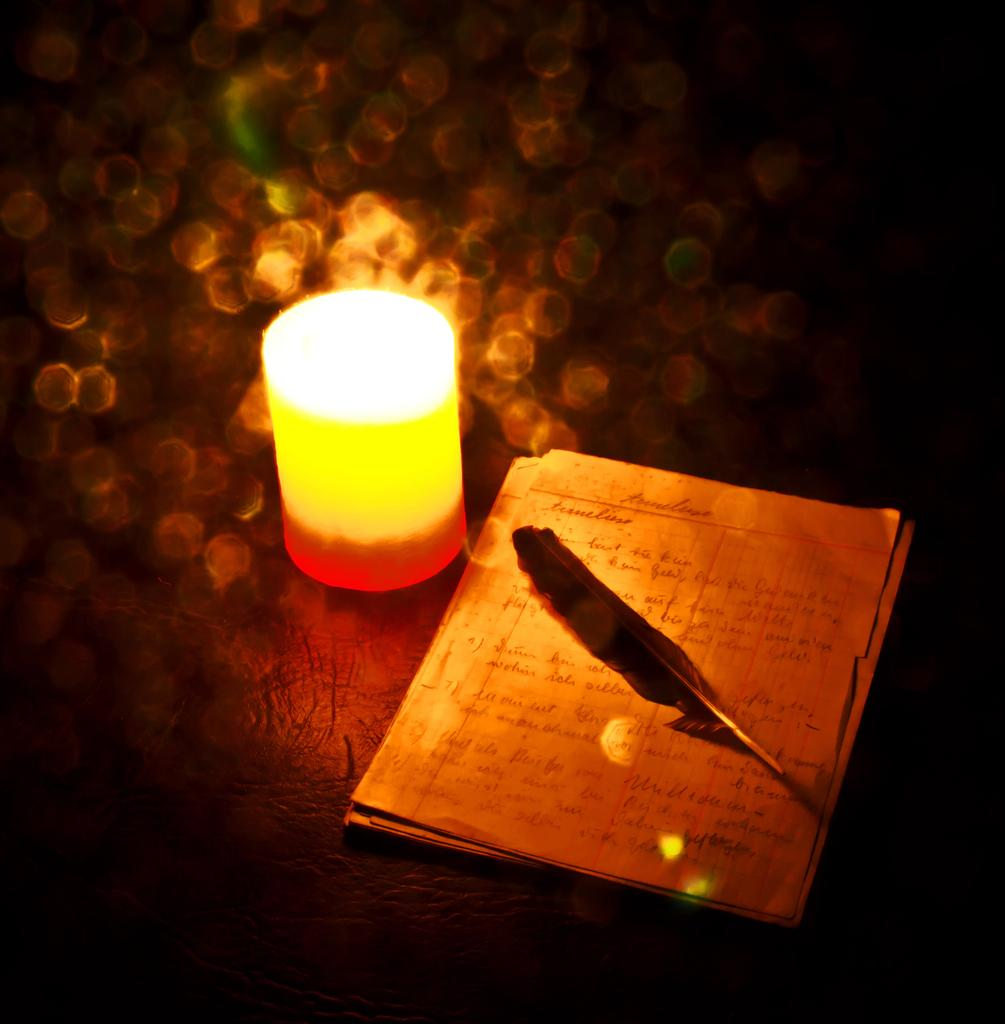What can be seen in the image that provides light? There is a light in the image. What is present on the papers in the image? There is a bird's feather on the papers in the image. How would you describe the background of the image? The background of the image is blurred. What type of string is being used to represent the nation in the image? There is no string or representation of a nation present in the image. How does the society depicted in the image interact with the bird's feather? There is no society depicted in the image, only a bird's feather on the papers. 